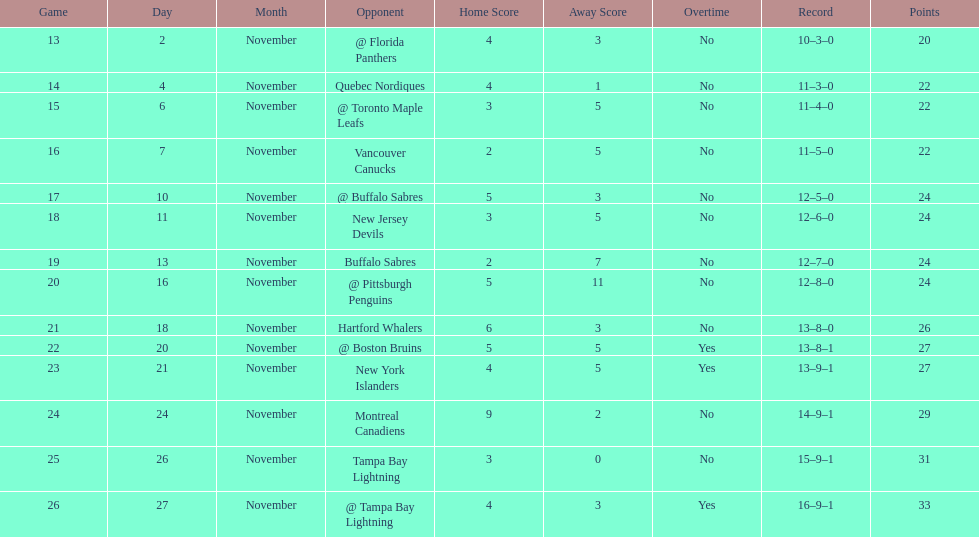Were the new jersey devils in last place according to the chart? No. 